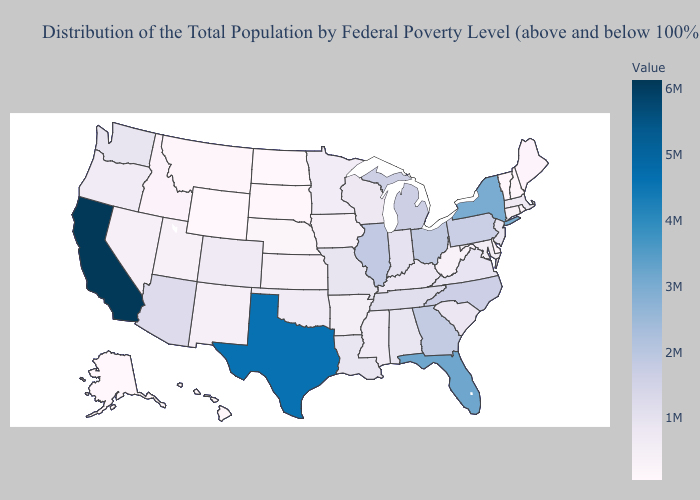Does Louisiana have the lowest value in the USA?
Be succinct. No. Among the states that border Iowa , which have the lowest value?
Quick response, please. South Dakota. Does Alaska have a higher value than Wisconsin?
Short answer required. No. Does the map have missing data?
Be succinct. No. Does North Dakota have the lowest value in the MidWest?
Short answer required. Yes. Among the states that border South Dakota , which have the highest value?
Answer briefly. Minnesota. 